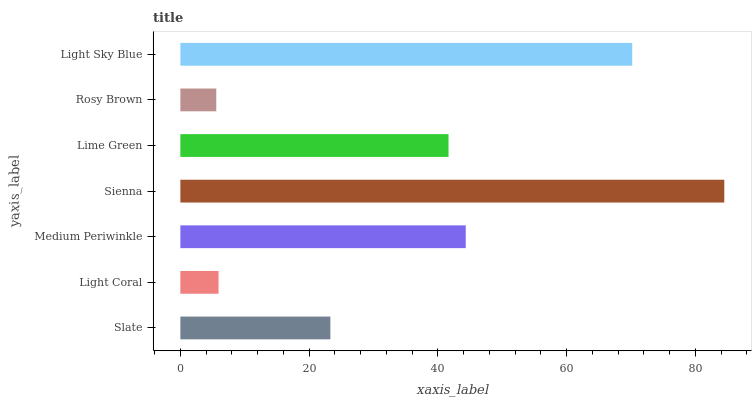Is Rosy Brown the minimum?
Answer yes or no. Yes. Is Sienna the maximum?
Answer yes or no. Yes. Is Light Coral the minimum?
Answer yes or no. No. Is Light Coral the maximum?
Answer yes or no. No. Is Slate greater than Light Coral?
Answer yes or no. Yes. Is Light Coral less than Slate?
Answer yes or no. Yes. Is Light Coral greater than Slate?
Answer yes or no. No. Is Slate less than Light Coral?
Answer yes or no. No. Is Lime Green the high median?
Answer yes or no. Yes. Is Lime Green the low median?
Answer yes or no. Yes. Is Medium Periwinkle the high median?
Answer yes or no. No. Is Sienna the low median?
Answer yes or no. No. 